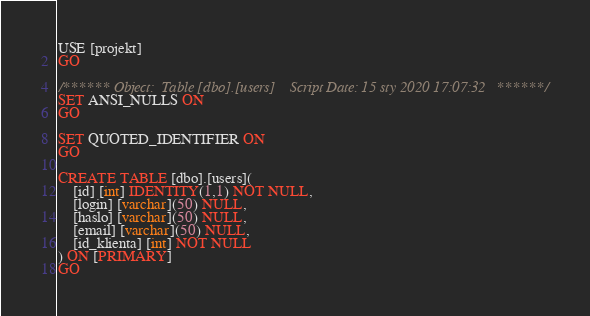<code> <loc_0><loc_0><loc_500><loc_500><_SQL_>USE [projekt]
GO

/****** Object:  Table [dbo].[users]    Script Date: 15 sty 2020 17:07:32 ******/
SET ANSI_NULLS ON
GO

SET QUOTED_IDENTIFIER ON
GO

CREATE TABLE [dbo].[users](
	[id] [int] IDENTITY(1,1) NOT NULL,
	[login] [varchar](50) NULL,
	[haslo] [varchar](50) NULL,
	[email] [varchar](50) NULL,
	[id_klienta] [int] NOT NULL
) ON [PRIMARY]
GO

</code> 